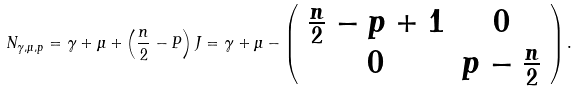<formula> <loc_0><loc_0><loc_500><loc_500>N _ { \gamma , \mu , p } = \gamma + \mu + \left ( \frac { n } { 2 } - P \right ) J = \gamma + \mu - \left ( \begin{array} { c c } \frac { n } { 2 } - p + 1 & 0 \\ 0 & p - \frac { n } { 2 } \end{array} \right ) .</formula> 